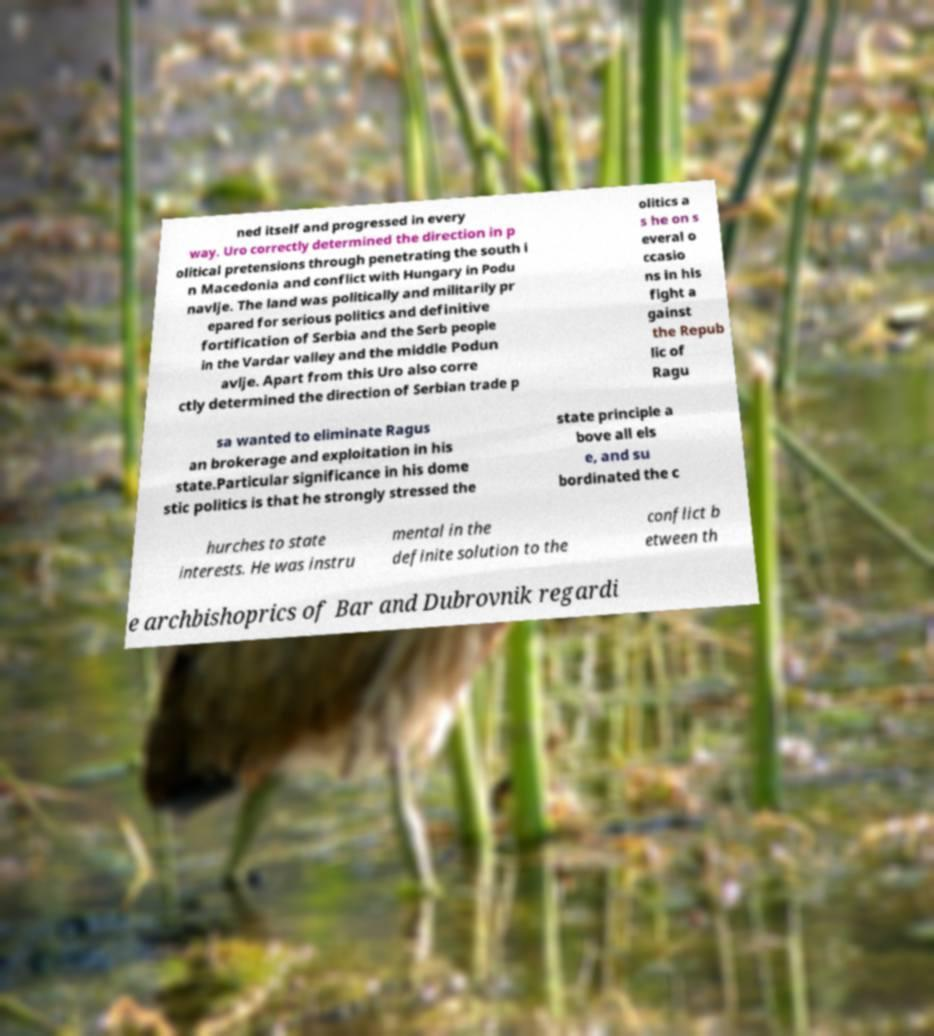Could you extract and type out the text from this image? ned itself and progressed in every way. Uro correctly determined the direction in p olitical pretensions through penetrating the south i n Macedonia and conflict with Hungary in Podu navlje. The land was politically and militarily pr epared for serious politics and definitive fortification of Serbia and the Serb people in the Vardar valley and the middle Podun avlje. Apart from this Uro also corre ctly determined the direction of Serbian trade p olitics a s he on s everal o ccasio ns in his fight a gainst the Repub lic of Ragu sa wanted to eliminate Ragus an brokerage and exploitation in his state.Particular significance in his dome stic politics is that he strongly stressed the state principle a bove all els e, and su bordinated the c hurches to state interests. He was instru mental in the definite solution to the conflict b etween th e archbishoprics of Bar and Dubrovnik regardi 